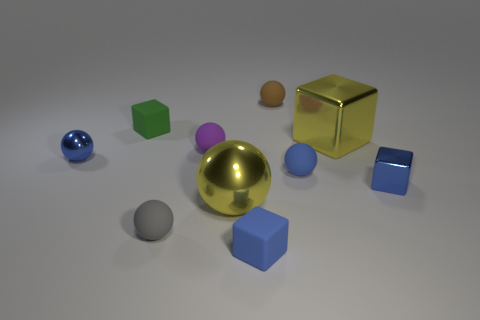Does the large shiny object that is to the right of the big sphere have the same shape as the tiny object behind the tiny green rubber cube?
Your answer should be very brief. No. Are there fewer gray objects right of the large metal ball than small purple things?
Give a very brief answer. Yes. What number of small metallic balls have the same color as the big metal cube?
Your response must be concise. 0. There is a yellow object that is behind the large shiny sphere; what size is it?
Make the answer very short. Large. What is the shape of the small blue thing in front of the blue block on the right side of the small blue rubber thing that is to the left of the brown object?
Ensure brevity in your answer.  Cube. There is a tiny blue thing that is on the right side of the green block and to the left of the small brown object; what shape is it?
Your answer should be compact. Cube. Are there any yellow metal objects of the same size as the yellow shiny sphere?
Give a very brief answer. Yes. Is the shape of the yellow metallic object that is on the left side of the small brown object the same as  the purple matte object?
Offer a terse response. Yes. Is the small brown rubber thing the same shape as the tiny gray thing?
Offer a very short reply. Yes. Is there a big yellow metallic object of the same shape as the tiny green rubber thing?
Provide a succinct answer. Yes. 